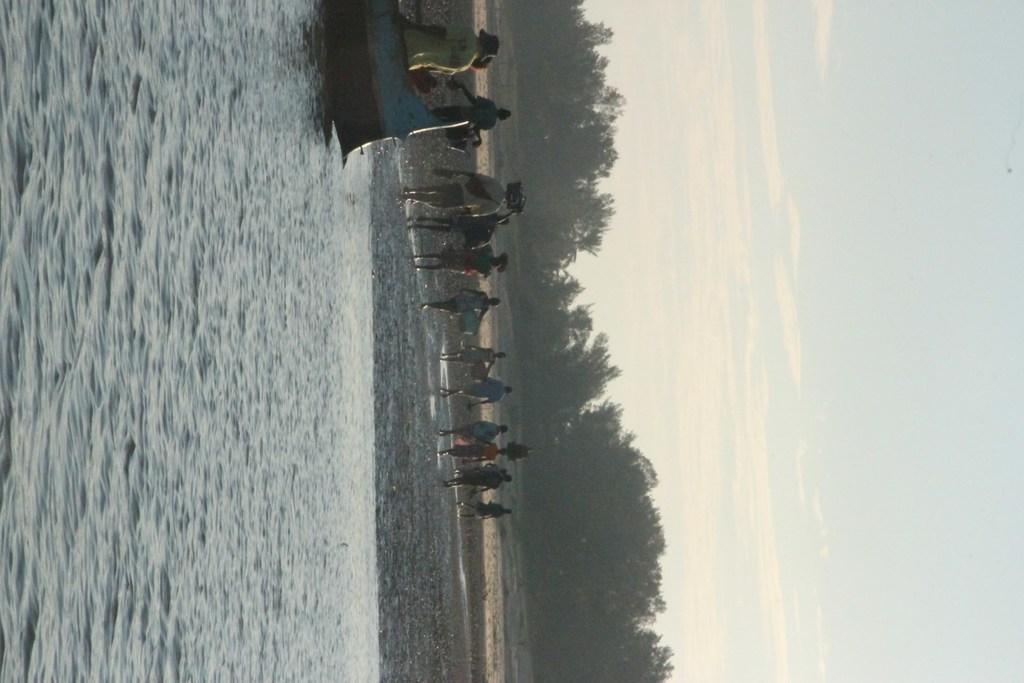How many people are in the image? There are many people in the image. Where are the people located in the image? The people are standing on the beach. What can be seen at the bottom of the image? There is water visible at the bottom of the image. What is visible on the right side of the image? The sky and clouds are visible on the right side of the image. What type of vegetation is in the background of the image? There are trees in the background of the image. What type of flower is growing in the kettle in the image? There is no flower or kettle present in the image. How many chickens are visible on the beach in the image? There are no chickens visible in the image; it features people standing on the beach. 